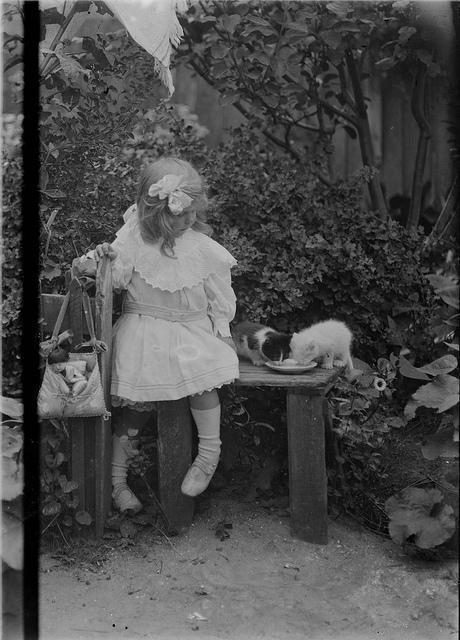How many cats are eating off the plate?
Give a very brief answer. 2. 